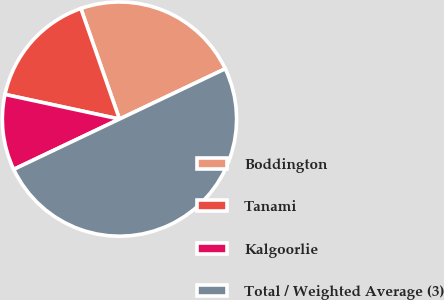Convert chart to OTSL. <chart><loc_0><loc_0><loc_500><loc_500><pie_chart><fcel>Boddington<fcel>Tanami<fcel>Kalgoorlie<fcel>Total / Weighted Average (3)<nl><fcel>23.28%<fcel>16.28%<fcel>10.44%<fcel>50.0%<nl></chart> 